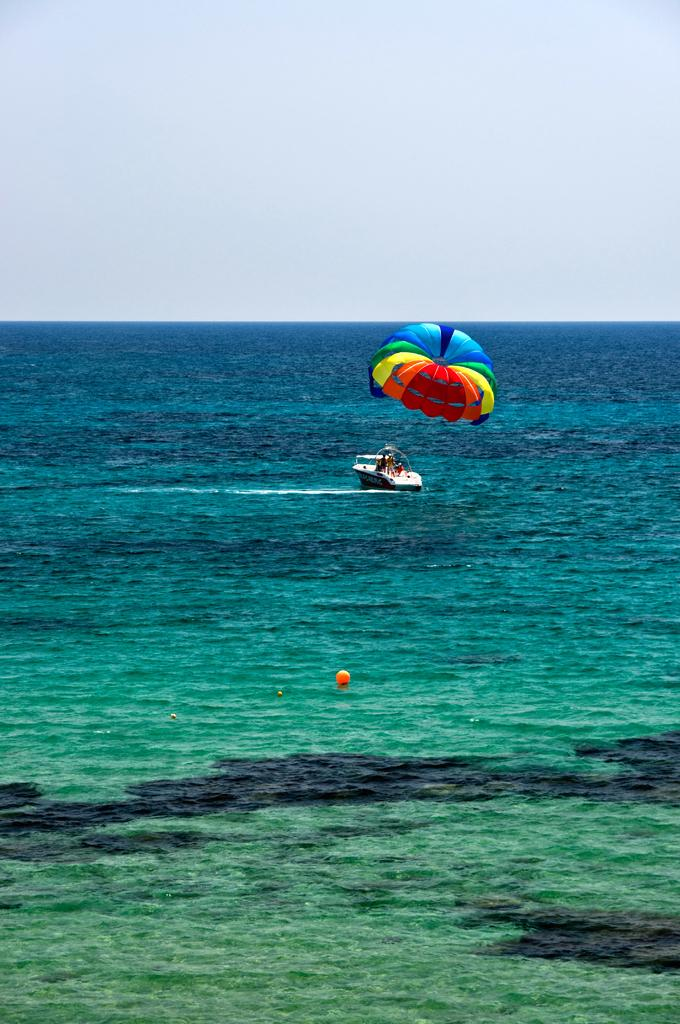Where was the picture taken? The picture was clicked outside the city. What can be seen in the foreground of the image? There is a water body in the foreground. What is present in the water body? There is a boat in the water body. What can be seen in the background of the image? The sky is visible in the background. What type of toy is being driven by the hands in the image? There are no hands or toys present in the image; it features a water body, a boat, and the sky. 